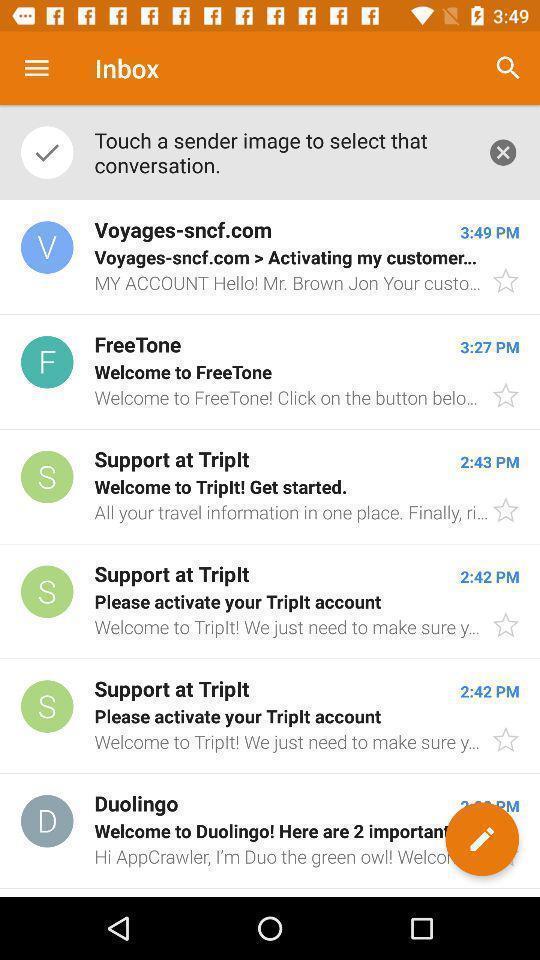Give me a narrative description of this picture. Screen shows multiple mails in inbox of a social app. 